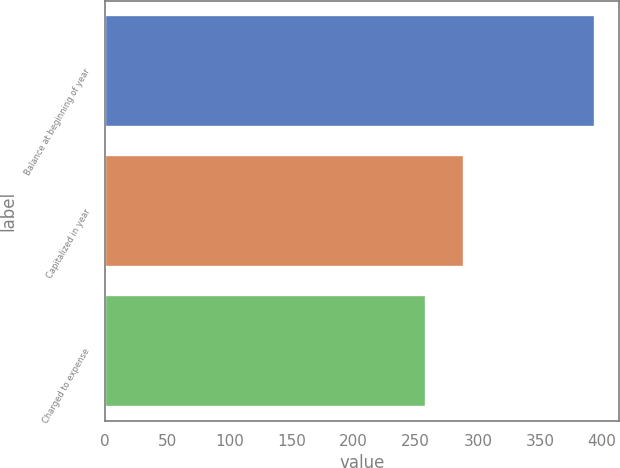<chart> <loc_0><loc_0><loc_500><loc_500><bar_chart><fcel>Balance at beginning of year<fcel>Capitalized in year<fcel>Charged to expense<nl><fcel>394<fcel>289<fcel>258<nl></chart> 